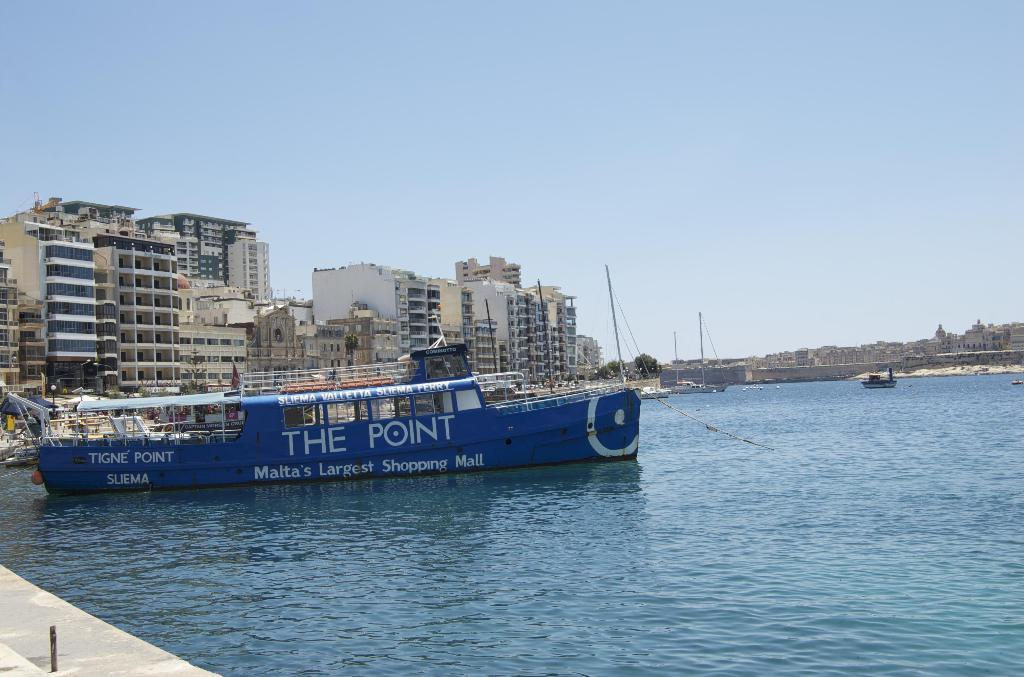<image>
Offer a succinct explanation of the picture presented. The Point is written on the side of a ship 